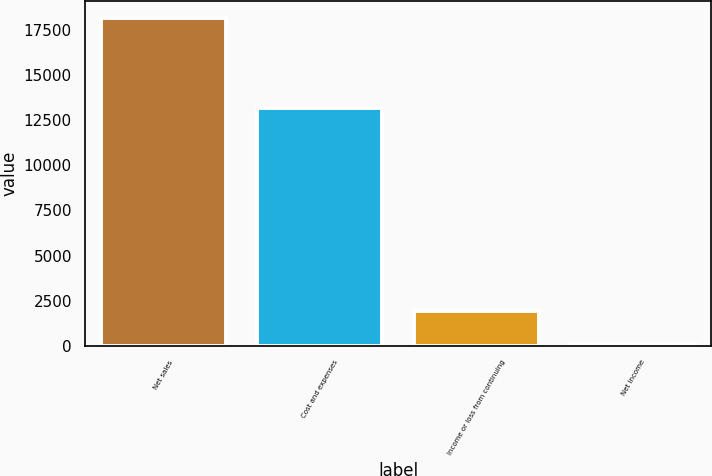Convert chart. <chart><loc_0><loc_0><loc_500><loc_500><bar_chart><fcel>Net sales<fcel>Cost and expenses<fcel>Income or loss from continuing<fcel>Net income<nl><fcel>18146<fcel>13177<fcel>1910.9<fcel>107<nl></chart> 